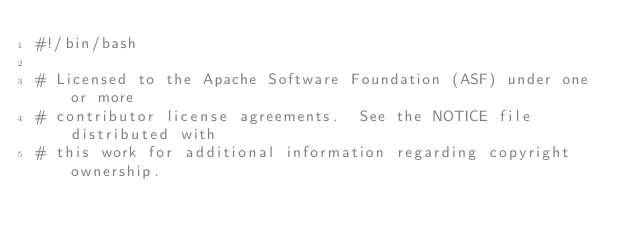Convert code to text. <code><loc_0><loc_0><loc_500><loc_500><_Bash_>#!/bin/bash

# Licensed to the Apache Software Foundation (ASF) under one or more
# contributor license agreements.  See the NOTICE file distributed with
# this work for additional information regarding copyright ownership.</code> 